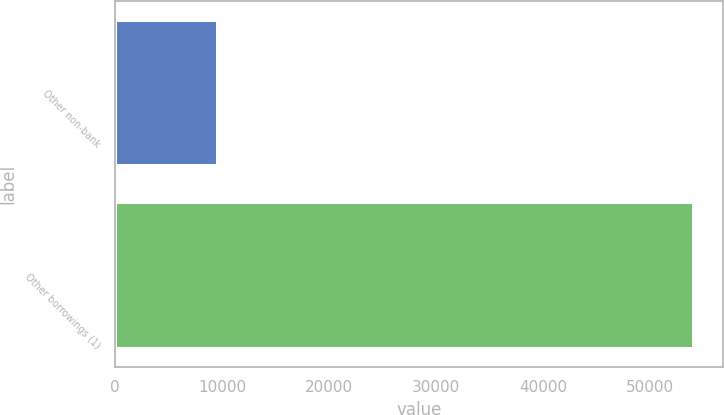Convert chart. <chart><loc_0><loc_0><loc_500><loc_500><bar_chart><fcel>Other non-bank<fcel>Other borrowings (1)<nl><fcel>9670<fcel>54133<nl></chart> 